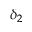<formula> <loc_0><loc_0><loc_500><loc_500>\delta _ { 2 }</formula> 